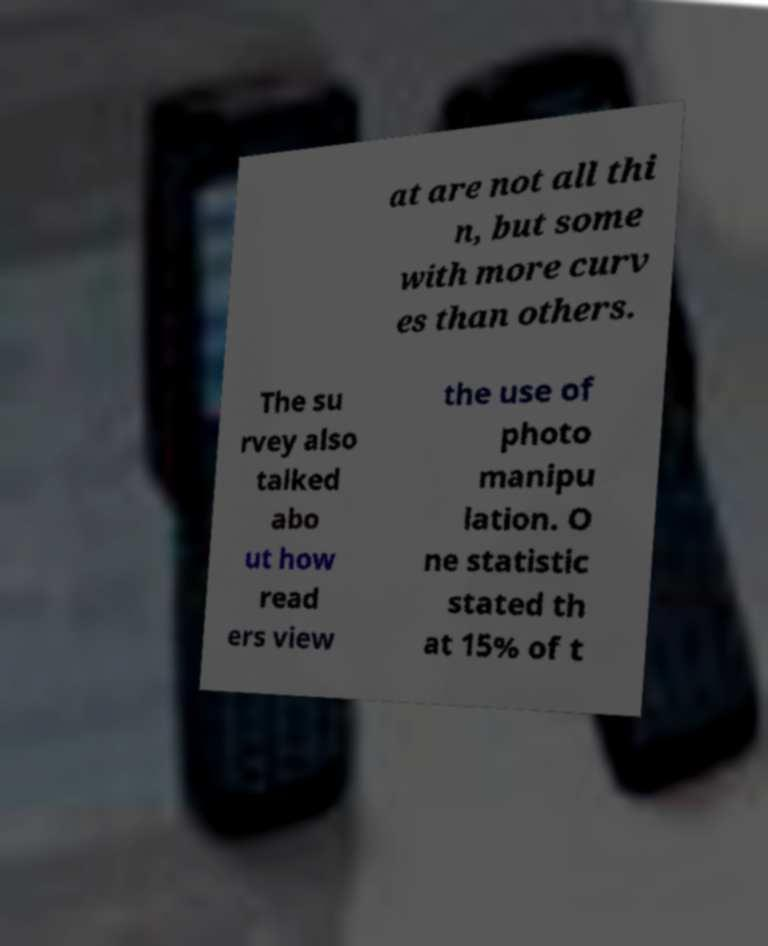There's text embedded in this image that I need extracted. Can you transcribe it verbatim? at are not all thi n, but some with more curv es than others. The su rvey also talked abo ut how read ers view the use of photo manipu lation. O ne statistic stated th at 15% of t 